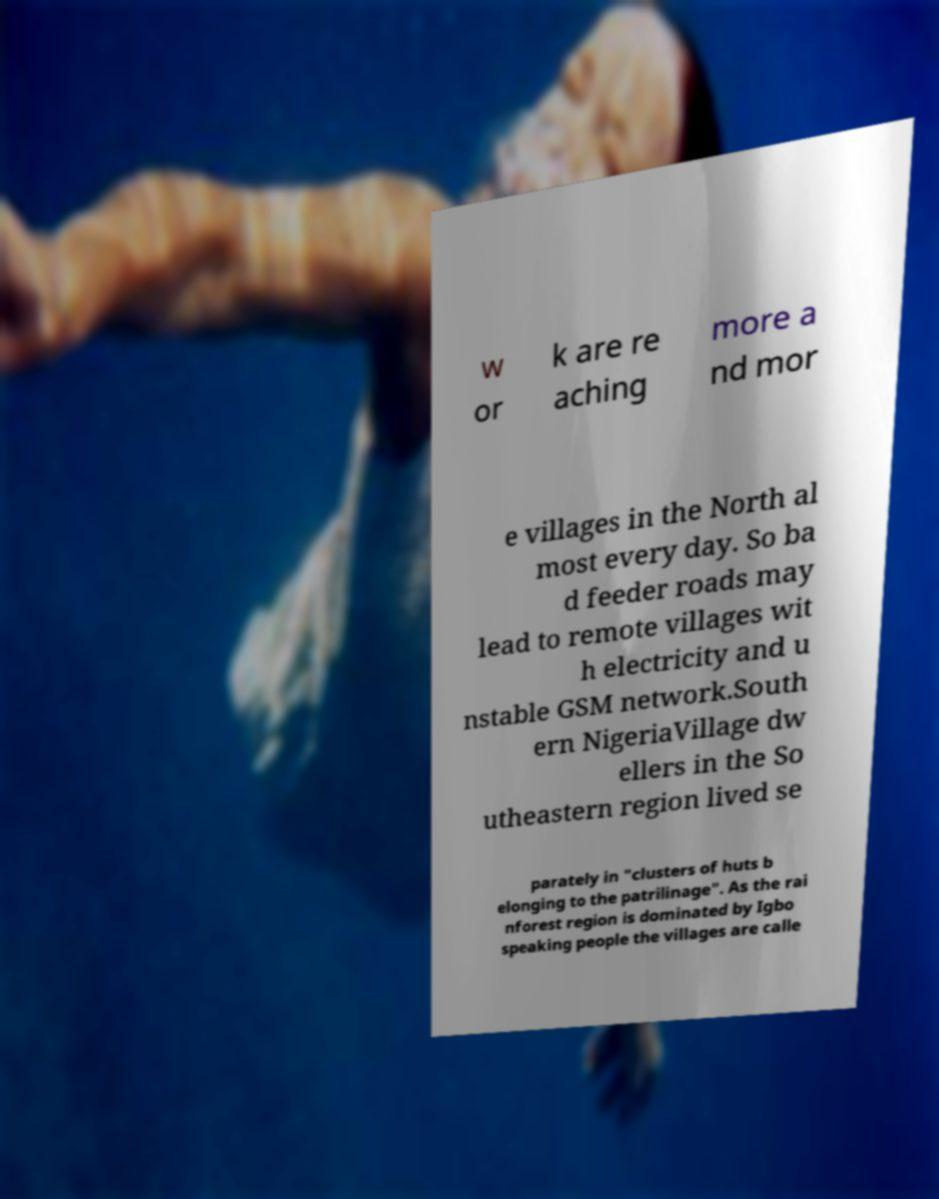I need the written content from this picture converted into text. Can you do that? w or k are re aching more a nd mor e villages in the North al most every day. So ba d feeder roads may lead to remote villages wit h electricity and u nstable GSM network.South ern NigeriaVillage dw ellers in the So utheastern region lived se parately in "clusters of huts b elonging to the patrilinage". As the rai nforest region is dominated by Igbo speaking people the villages are calle 